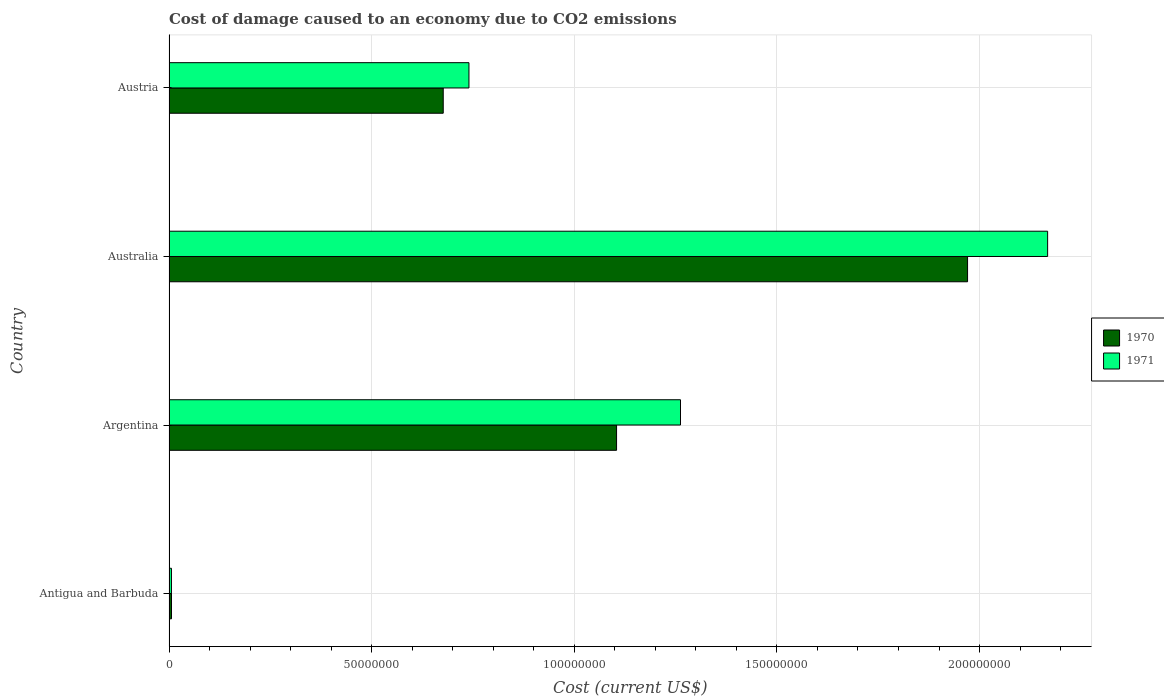How many different coloured bars are there?
Your answer should be compact. 2. How many groups of bars are there?
Ensure brevity in your answer.  4. Are the number of bars per tick equal to the number of legend labels?
Make the answer very short. Yes. What is the label of the 4th group of bars from the top?
Offer a terse response. Antigua and Barbuda. In how many cases, is the number of bars for a given country not equal to the number of legend labels?
Give a very brief answer. 0. What is the cost of damage caused due to CO2 emissisons in 1971 in Australia?
Make the answer very short. 2.17e+08. Across all countries, what is the maximum cost of damage caused due to CO2 emissisons in 1970?
Provide a succinct answer. 1.97e+08. Across all countries, what is the minimum cost of damage caused due to CO2 emissisons in 1971?
Ensure brevity in your answer.  6.04e+05. In which country was the cost of damage caused due to CO2 emissisons in 1970 maximum?
Keep it short and to the point. Australia. In which country was the cost of damage caused due to CO2 emissisons in 1971 minimum?
Keep it short and to the point. Antigua and Barbuda. What is the total cost of damage caused due to CO2 emissisons in 1971 in the graph?
Provide a short and direct response. 4.18e+08. What is the difference between the cost of damage caused due to CO2 emissisons in 1971 in Antigua and Barbuda and that in Australia?
Offer a terse response. -2.16e+08. What is the difference between the cost of damage caused due to CO2 emissisons in 1970 in Austria and the cost of damage caused due to CO2 emissisons in 1971 in Argentina?
Keep it short and to the point. -5.85e+07. What is the average cost of damage caused due to CO2 emissisons in 1970 per country?
Keep it short and to the point. 9.39e+07. What is the difference between the cost of damage caused due to CO2 emissisons in 1970 and cost of damage caused due to CO2 emissisons in 1971 in Antigua and Barbuda?
Keep it short and to the point. 1.31e+04. In how many countries, is the cost of damage caused due to CO2 emissisons in 1970 greater than 30000000 US$?
Provide a succinct answer. 3. What is the ratio of the cost of damage caused due to CO2 emissisons in 1971 in Australia to that in Austria?
Make the answer very short. 2.93. Is the cost of damage caused due to CO2 emissisons in 1970 in Australia less than that in Austria?
Keep it short and to the point. No. What is the difference between the highest and the second highest cost of damage caused due to CO2 emissisons in 1970?
Provide a succinct answer. 8.66e+07. What is the difference between the highest and the lowest cost of damage caused due to CO2 emissisons in 1970?
Give a very brief answer. 1.96e+08. What does the 1st bar from the top in Antigua and Barbuda represents?
Your answer should be compact. 1971. How many bars are there?
Your answer should be compact. 8. What is the difference between two consecutive major ticks on the X-axis?
Offer a terse response. 5.00e+07. Does the graph contain any zero values?
Give a very brief answer. No. Does the graph contain grids?
Offer a very short reply. Yes. Where does the legend appear in the graph?
Provide a short and direct response. Center right. How many legend labels are there?
Provide a short and direct response. 2. How are the legend labels stacked?
Give a very brief answer. Vertical. What is the title of the graph?
Offer a terse response. Cost of damage caused to an economy due to CO2 emissions. What is the label or title of the X-axis?
Provide a short and direct response. Cost (current US$). What is the label or title of the Y-axis?
Make the answer very short. Country. What is the Cost (current US$) in 1970 in Antigua and Barbuda?
Keep it short and to the point. 6.17e+05. What is the Cost (current US$) in 1971 in Antigua and Barbuda?
Keep it short and to the point. 6.04e+05. What is the Cost (current US$) in 1970 in Argentina?
Your answer should be very brief. 1.10e+08. What is the Cost (current US$) in 1971 in Argentina?
Offer a terse response. 1.26e+08. What is the Cost (current US$) of 1970 in Australia?
Your response must be concise. 1.97e+08. What is the Cost (current US$) of 1971 in Australia?
Provide a short and direct response. 2.17e+08. What is the Cost (current US$) in 1970 in Austria?
Your response must be concise. 6.77e+07. What is the Cost (current US$) of 1971 in Austria?
Give a very brief answer. 7.40e+07. Across all countries, what is the maximum Cost (current US$) in 1970?
Offer a very short reply. 1.97e+08. Across all countries, what is the maximum Cost (current US$) in 1971?
Provide a short and direct response. 2.17e+08. Across all countries, what is the minimum Cost (current US$) in 1970?
Your answer should be compact. 6.17e+05. Across all countries, what is the minimum Cost (current US$) of 1971?
Your response must be concise. 6.04e+05. What is the total Cost (current US$) of 1970 in the graph?
Make the answer very short. 3.76e+08. What is the total Cost (current US$) in 1971 in the graph?
Provide a succinct answer. 4.18e+08. What is the difference between the Cost (current US$) in 1970 in Antigua and Barbuda and that in Argentina?
Provide a succinct answer. -1.10e+08. What is the difference between the Cost (current US$) in 1971 in Antigua and Barbuda and that in Argentina?
Give a very brief answer. -1.26e+08. What is the difference between the Cost (current US$) of 1970 in Antigua and Barbuda and that in Australia?
Provide a short and direct response. -1.96e+08. What is the difference between the Cost (current US$) of 1971 in Antigua and Barbuda and that in Australia?
Give a very brief answer. -2.16e+08. What is the difference between the Cost (current US$) in 1970 in Antigua and Barbuda and that in Austria?
Your answer should be very brief. -6.70e+07. What is the difference between the Cost (current US$) of 1971 in Antigua and Barbuda and that in Austria?
Ensure brevity in your answer.  -7.34e+07. What is the difference between the Cost (current US$) of 1970 in Argentina and that in Australia?
Your answer should be compact. -8.66e+07. What is the difference between the Cost (current US$) of 1971 in Argentina and that in Australia?
Provide a short and direct response. -9.06e+07. What is the difference between the Cost (current US$) in 1970 in Argentina and that in Austria?
Keep it short and to the point. 4.28e+07. What is the difference between the Cost (current US$) of 1971 in Argentina and that in Austria?
Your response must be concise. 5.22e+07. What is the difference between the Cost (current US$) in 1970 in Australia and that in Austria?
Provide a short and direct response. 1.29e+08. What is the difference between the Cost (current US$) of 1971 in Australia and that in Austria?
Keep it short and to the point. 1.43e+08. What is the difference between the Cost (current US$) in 1970 in Antigua and Barbuda and the Cost (current US$) in 1971 in Argentina?
Your answer should be compact. -1.26e+08. What is the difference between the Cost (current US$) of 1970 in Antigua and Barbuda and the Cost (current US$) of 1971 in Australia?
Your response must be concise. -2.16e+08. What is the difference between the Cost (current US$) in 1970 in Antigua and Barbuda and the Cost (current US$) in 1971 in Austria?
Make the answer very short. -7.34e+07. What is the difference between the Cost (current US$) in 1970 in Argentina and the Cost (current US$) in 1971 in Australia?
Ensure brevity in your answer.  -1.06e+08. What is the difference between the Cost (current US$) of 1970 in Argentina and the Cost (current US$) of 1971 in Austria?
Your answer should be compact. 3.64e+07. What is the difference between the Cost (current US$) of 1970 in Australia and the Cost (current US$) of 1971 in Austria?
Ensure brevity in your answer.  1.23e+08. What is the average Cost (current US$) of 1970 per country?
Ensure brevity in your answer.  9.39e+07. What is the average Cost (current US$) of 1971 per country?
Provide a succinct answer. 1.04e+08. What is the difference between the Cost (current US$) of 1970 and Cost (current US$) of 1971 in Antigua and Barbuda?
Your answer should be very brief. 1.31e+04. What is the difference between the Cost (current US$) in 1970 and Cost (current US$) in 1971 in Argentina?
Make the answer very short. -1.58e+07. What is the difference between the Cost (current US$) in 1970 and Cost (current US$) in 1971 in Australia?
Ensure brevity in your answer.  -1.98e+07. What is the difference between the Cost (current US$) in 1970 and Cost (current US$) in 1971 in Austria?
Provide a short and direct response. -6.35e+06. What is the ratio of the Cost (current US$) in 1970 in Antigua and Barbuda to that in Argentina?
Provide a short and direct response. 0.01. What is the ratio of the Cost (current US$) in 1971 in Antigua and Barbuda to that in Argentina?
Ensure brevity in your answer.  0. What is the ratio of the Cost (current US$) in 1970 in Antigua and Barbuda to that in Australia?
Make the answer very short. 0. What is the ratio of the Cost (current US$) of 1971 in Antigua and Barbuda to that in Australia?
Your answer should be very brief. 0. What is the ratio of the Cost (current US$) in 1970 in Antigua and Barbuda to that in Austria?
Offer a very short reply. 0.01. What is the ratio of the Cost (current US$) of 1971 in Antigua and Barbuda to that in Austria?
Keep it short and to the point. 0.01. What is the ratio of the Cost (current US$) of 1970 in Argentina to that in Australia?
Your answer should be compact. 0.56. What is the ratio of the Cost (current US$) of 1971 in Argentina to that in Australia?
Your answer should be compact. 0.58. What is the ratio of the Cost (current US$) in 1970 in Argentina to that in Austria?
Keep it short and to the point. 1.63. What is the ratio of the Cost (current US$) of 1971 in Argentina to that in Austria?
Your response must be concise. 1.71. What is the ratio of the Cost (current US$) in 1970 in Australia to that in Austria?
Give a very brief answer. 2.91. What is the ratio of the Cost (current US$) in 1971 in Australia to that in Austria?
Provide a short and direct response. 2.93. What is the difference between the highest and the second highest Cost (current US$) in 1970?
Your response must be concise. 8.66e+07. What is the difference between the highest and the second highest Cost (current US$) of 1971?
Offer a very short reply. 9.06e+07. What is the difference between the highest and the lowest Cost (current US$) of 1970?
Offer a terse response. 1.96e+08. What is the difference between the highest and the lowest Cost (current US$) in 1971?
Keep it short and to the point. 2.16e+08. 